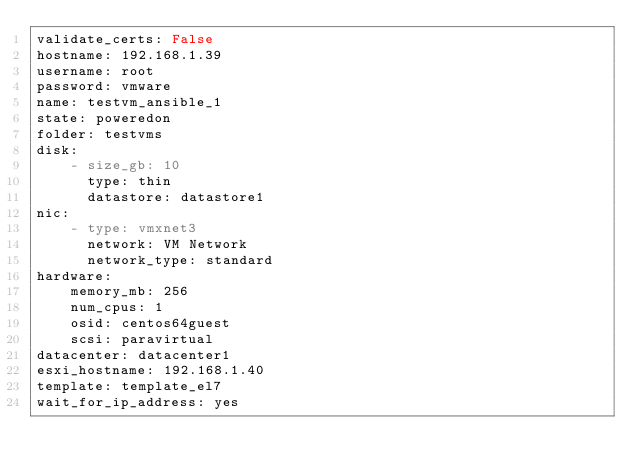<code> <loc_0><loc_0><loc_500><loc_500><_YAML_>validate_certs: False
hostname: 192.168.1.39
username: root
password: vmware
name: testvm_ansible_1
state: poweredon
folder: testvms
disk:
    - size_gb: 10
      type: thin
      datastore: datastore1
nic:
    - type: vmxnet3
      network: VM Network
      network_type: standard
hardware:
    memory_mb: 256
    num_cpus: 1
    osid: centos64guest
    scsi: paravirtual
datacenter: datacenter1
esxi_hostname: 192.168.1.40
template: template_el7
wait_for_ip_address: yes
</code> 